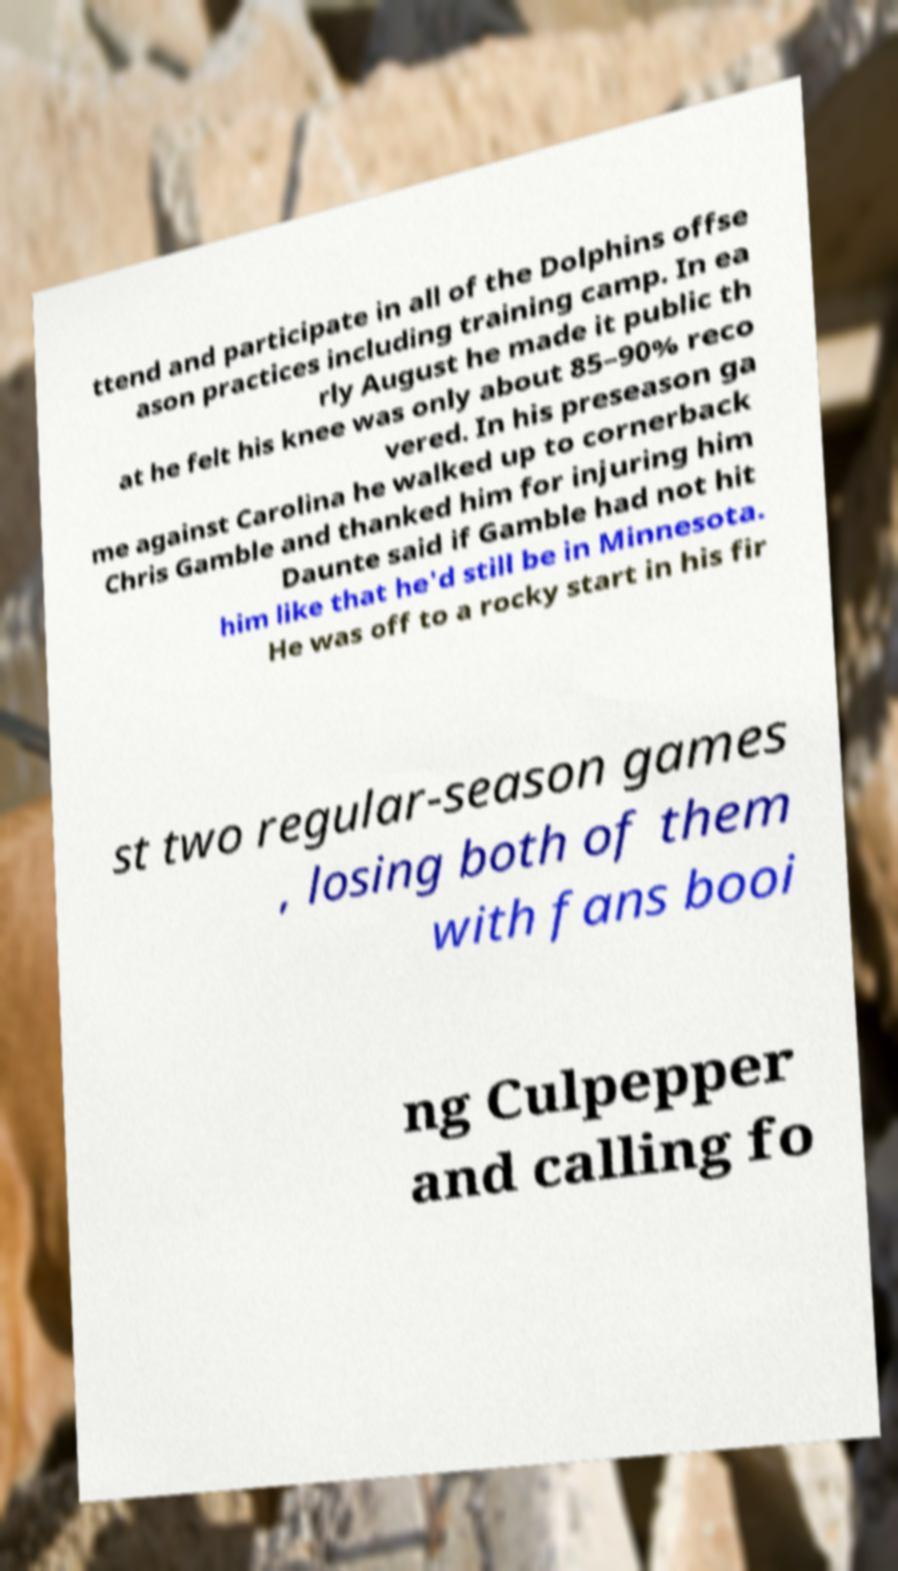Could you extract and type out the text from this image? ttend and participate in all of the Dolphins offse ason practices including training camp. In ea rly August he made it public th at he felt his knee was only about 85–90% reco vered. In his preseason ga me against Carolina he walked up to cornerback Chris Gamble and thanked him for injuring him Daunte said if Gamble had not hit him like that he'd still be in Minnesota. He was off to a rocky start in his fir st two regular-season games , losing both of them with fans booi ng Culpepper and calling fo 